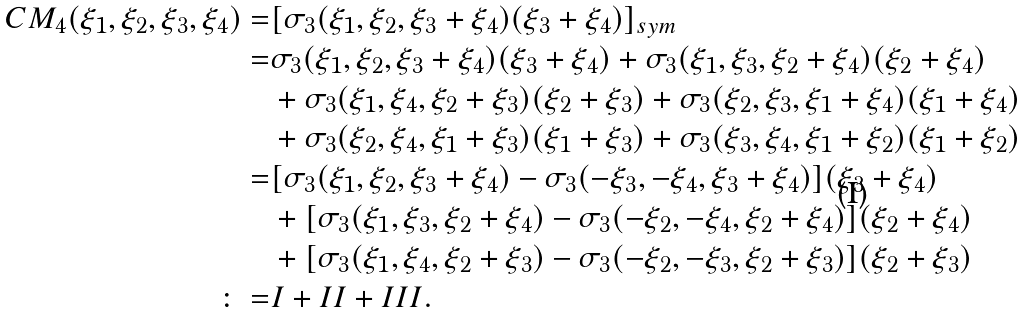Convert formula to latex. <formula><loc_0><loc_0><loc_500><loc_500>C M _ { 4 } ( \xi _ { 1 } , \xi _ { 2 } , \xi _ { 3 } , \xi _ { 4 } ) = & [ \sigma _ { 3 } ( \xi _ { 1 } , \xi _ { 2 } , \xi _ { 3 } + \xi _ { 4 } ) ( \xi _ { 3 } + \xi _ { 4 } ) ] _ { s y m } \\ = & \sigma _ { 3 } ( \xi _ { 1 } , \xi _ { 2 } , \xi _ { 3 } + \xi _ { 4 } ) ( \xi _ { 3 } + \xi _ { 4 } ) + \sigma _ { 3 } ( \xi _ { 1 } , \xi _ { 3 } , \xi _ { 2 } + \xi _ { 4 } ) ( \xi _ { 2 } + \xi _ { 4 } ) \\ & + \sigma _ { 3 } ( \xi _ { 1 } , \xi _ { 4 } , \xi _ { 2 } + \xi _ { 3 } ) ( \xi _ { 2 } + \xi _ { 3 } ) + \sigma _ { 3 } ( \xi _ { 2 } , \xi _ { 3 } , \xi _ { 1 } + \xi _ { 4 } ) ( \xi _ { 1 } + \xi _ { 4 } ) \\ & + \sigma _ { 3 } ( \xi _ { 2 } , \xi _ { 4 } , \xi _ { 1 } + \xi _ { 3 } ) ( \xi _ { 1 } + \xi _ { 3 } ) + \sigma _ { 3 } ( \xi _ { 3 } , \xi _ { 4 } , \xi _ { 1 } + \xi _ { 2 } ) ( \xi _ { 1 } + \xi _ { 2 } ) \\ = & [ \sigma _ { 3 } ( \xi _ { 1 } , \xi _ { 2 } , \xi _ { 3 } + \xi _ { 4 } ) - \sigma _ { 3 } ( - \xi _ { 3 } , - \xi _ { 4 } , \xi _ { 3 } + \xi _ { 4 } ) ] ( \xi _ { 3 } + \xi _ { 4 } ) \\ & + [ \sigma _ { 3 } ( \xi _ { 1 } , \xi _ { 3 } , \xi _ { 2 } + \xi _ { 4 } ) - \sigma _ { 3 } ( - \xi _ { 2 } , - \xi _ { 4 } , \xi _ { 2 } + \xi _ { 4 } ) ] ( \xi _ { 2 } + \xi _ { 4 } ) \\ & + [ \sigma _ { 3 } ( \xi _ { 1 } , \xi _ { 4 } , \xi _ { 2 } + \xi _ { 3 } ) - \sigma _ { 3 } ( - \xi _ { 2 } , - \xi _ { 3 } , \xi _ { 2 } + \xi _ { 3 } ) ] ( \xi _ { 2 } + \xi _ { 3 } ) \\ \colon = & I + I I + I I I .</formula> 